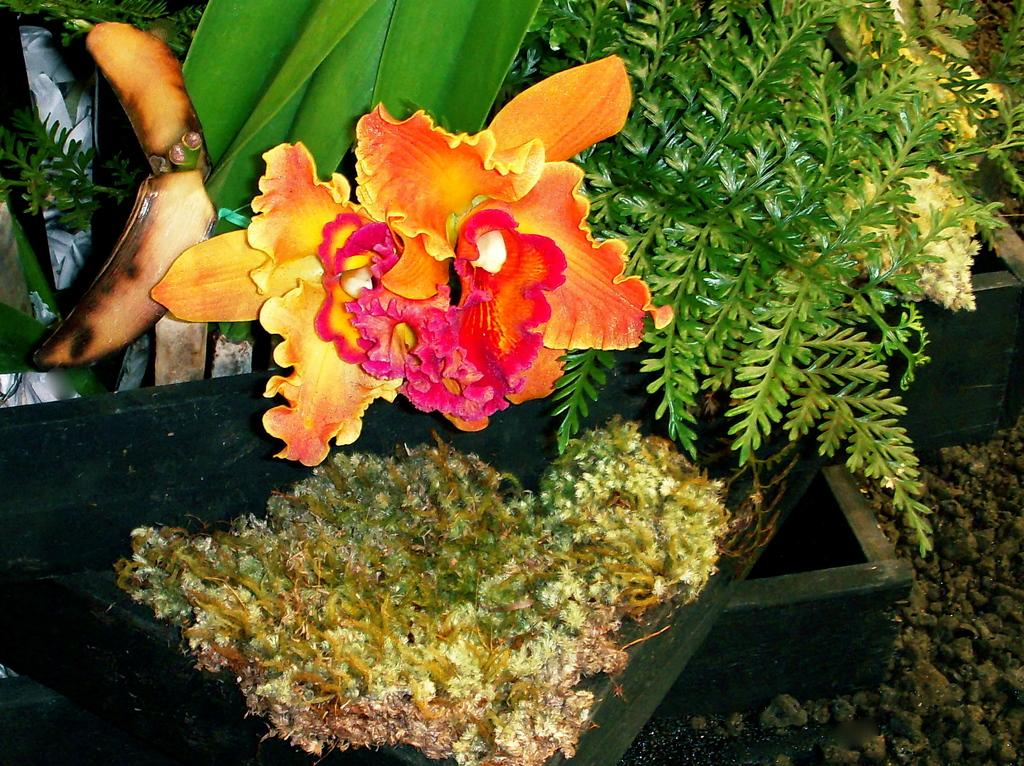What type of living organisms can be seen in the image? Plants and a flower are visible in the image. Can you describe the main subject of the image? The main subject of the image is a flower. What else can be seen in the image besides the plants and flower? There are objects in the image. What is the surface on which the objects are placed? The ground is visible in the image, and there are objects on the ground. What type of instrument is being played by the plant in the image? There is no instrument being played by a plant in the image, as plants do not have the ability to play instruments. 